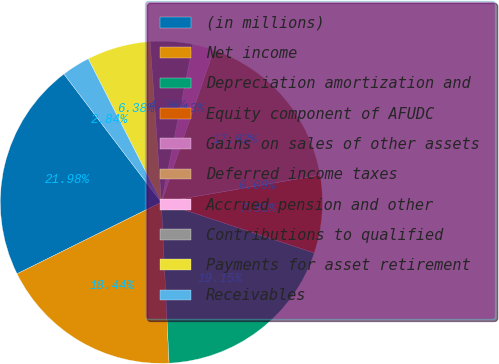Convert chart to OTSL. <chart><loc_0><loc_0><loc_500><loc_500><pie_chart><fcel>(in millions)<fcel>Net income<fcel>Depreciation amortization and<fcel>Equity component of AFUDC<fcel>Gains on sales of other assets<fcel>Deferred income taxes<fcel>Accrued pension and other<fcel>Contributions to qualified<fcel>Payments for asset retirement<fcel>Receivables<nl><fcel>21.98%<fcel>18.44%<fcel>19.15%<fcel>7.8%<fcel>0.0%<fcel>17.02%<fcel>2.13%<fcel>4.26%<fcel>6.38%<fcel>2.84%<nl></chart> 